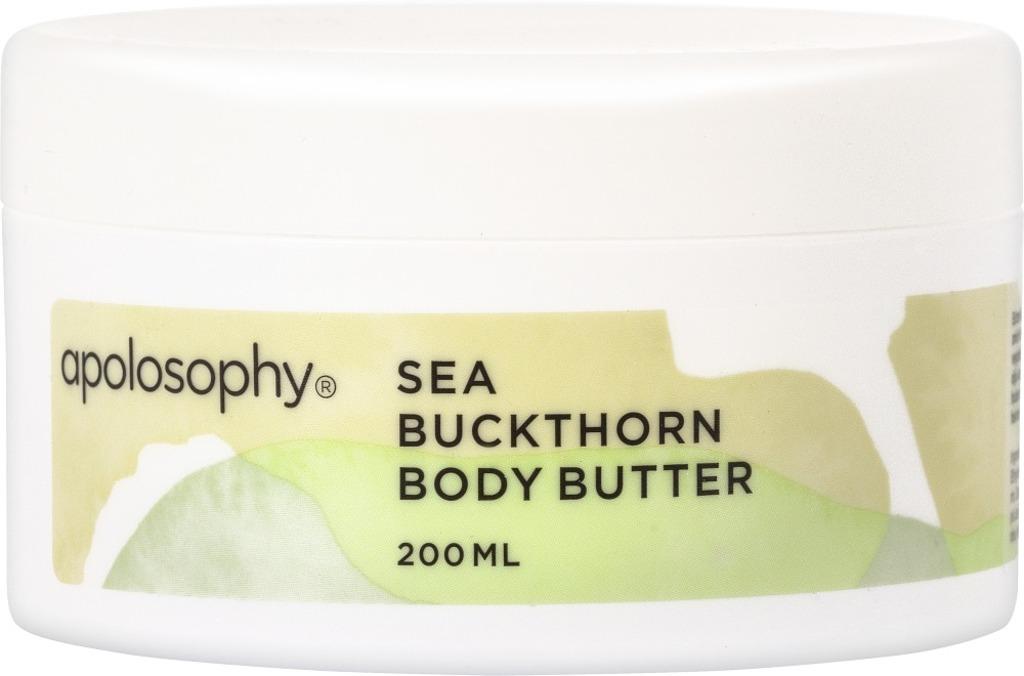What brand is the body butter?
Your answer should be compact. Apolosophy. 